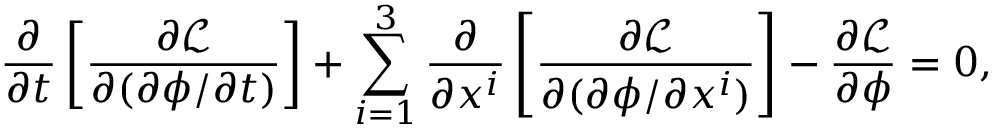Convert formula to latex. <formula><loc_0><loc_0><loc_500><loc_500>{ \frac { \partial } { \partial t } } \left [ { \frac { \partial { \mathcal { L } } } { \partial ( \partial \phi / \partial t ) } } \right ] + \sum _ { i = 1 } ^ { 3 } { \frac { \partial } { \partial x ^ { i } } } \left [ { \frac { \partial { \mathcal { L } } } { \partial ( \partial \phi / \partial x ^ { i } ) } } \right ] - { \frac { \partial { \mathcal { L } } } { \partial \phi } } = 0 ,</formula> 